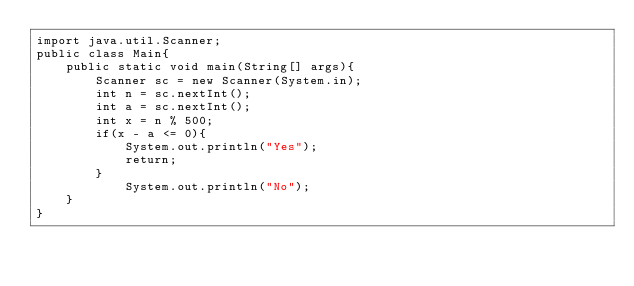<code> <loc_0><loc_0><loc_500><loc_500><_Java_>import java.util.Scanner;
public class Main{
    public static void main(String[] args){
        Scanner sc = new Scanner(System.in);
        int n = sc.nextInt();
        int a = sc.nextInt();
        int x = n % 500;
        if(x - a <= 0){
            System.out.println("Yes");
            return;
        }
            System.out.println("No");
    }
}
</code> 